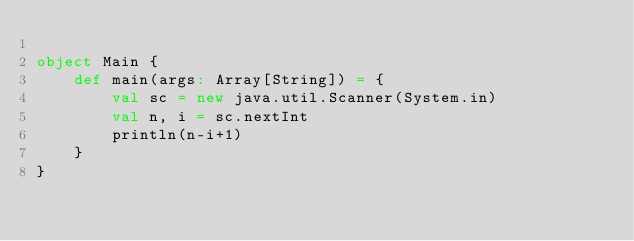Convert code to text. <code><loc_0><loc_0><loc_500><loc_500><_Scala_>
object Main {
    def main(args: Array[String]) = {
        val sc = new java.util.Scanner(System.in)
        val n, i = sc.nextInt
        println(n-i+1)
    }
}
</code> 